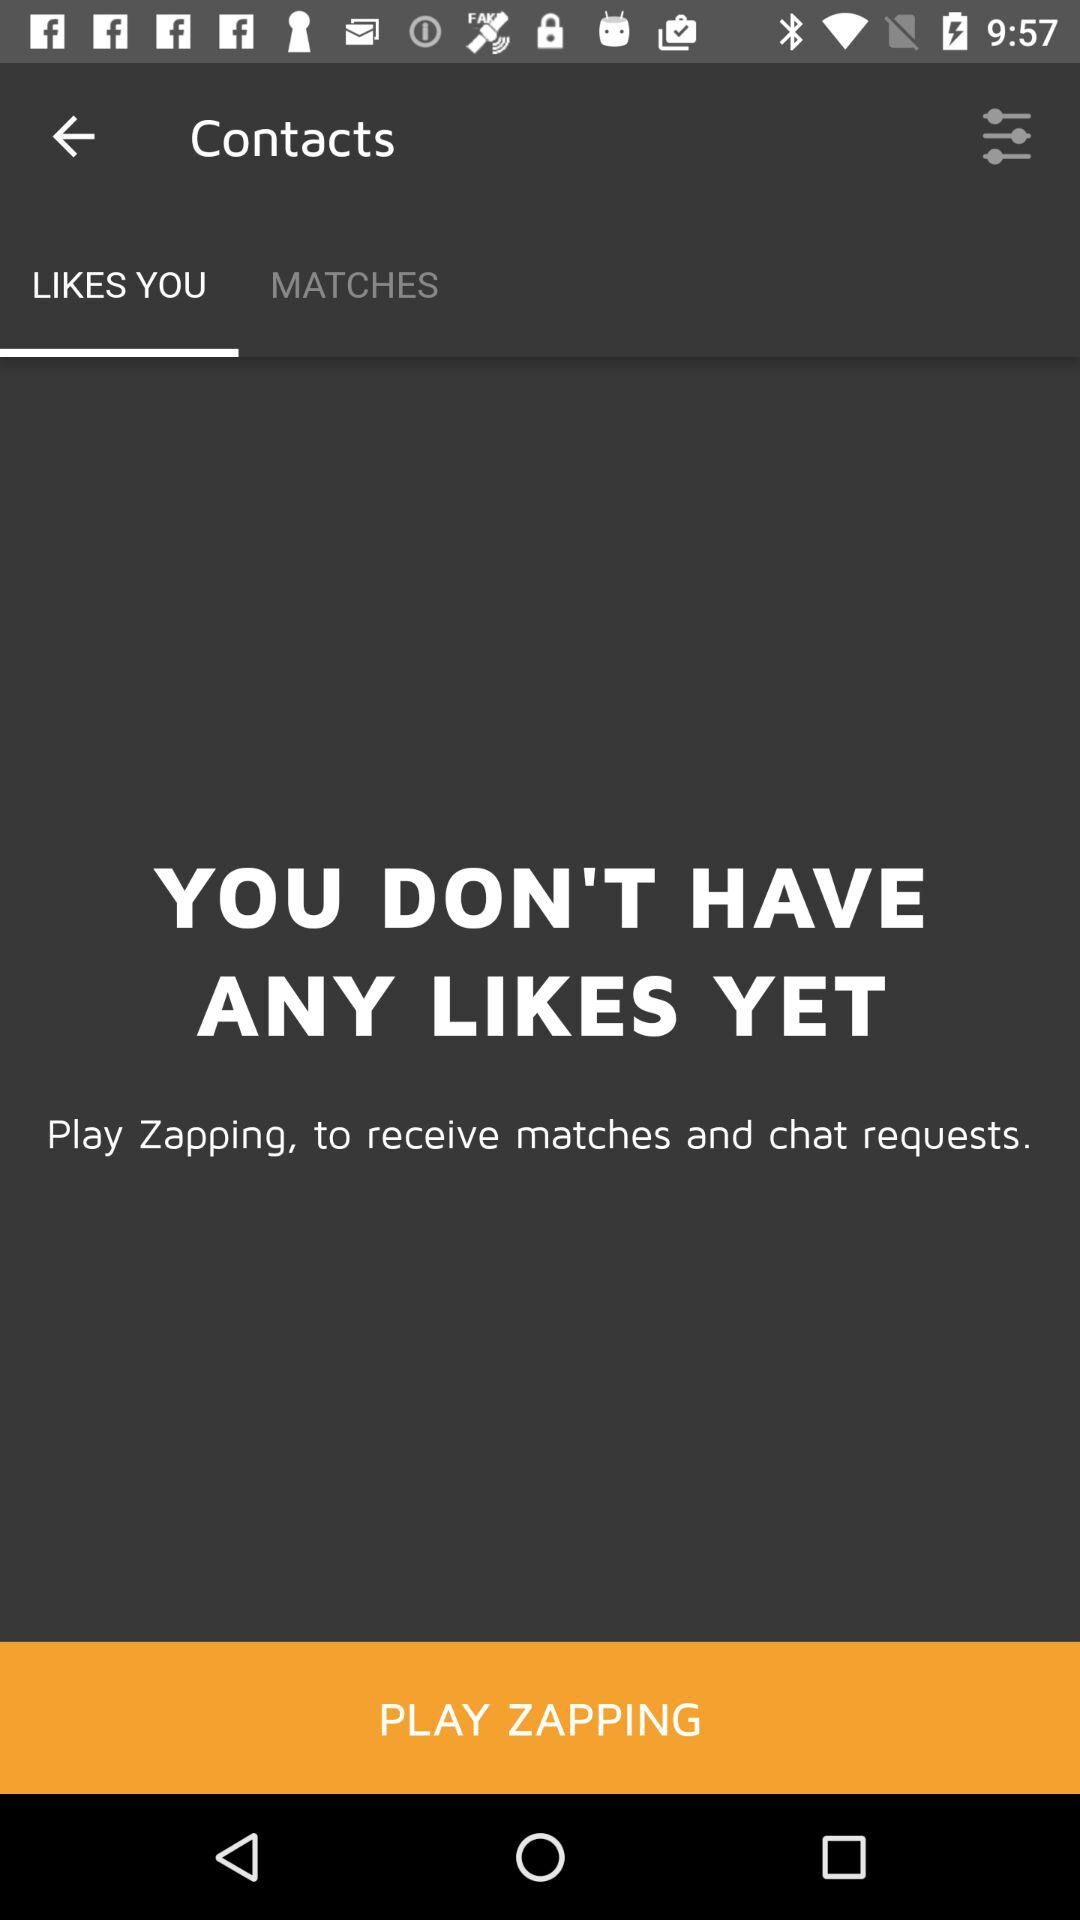What app can be used to receive matches and chat requests? The app that can be used to receive matches and chat requests is "Zapping". 